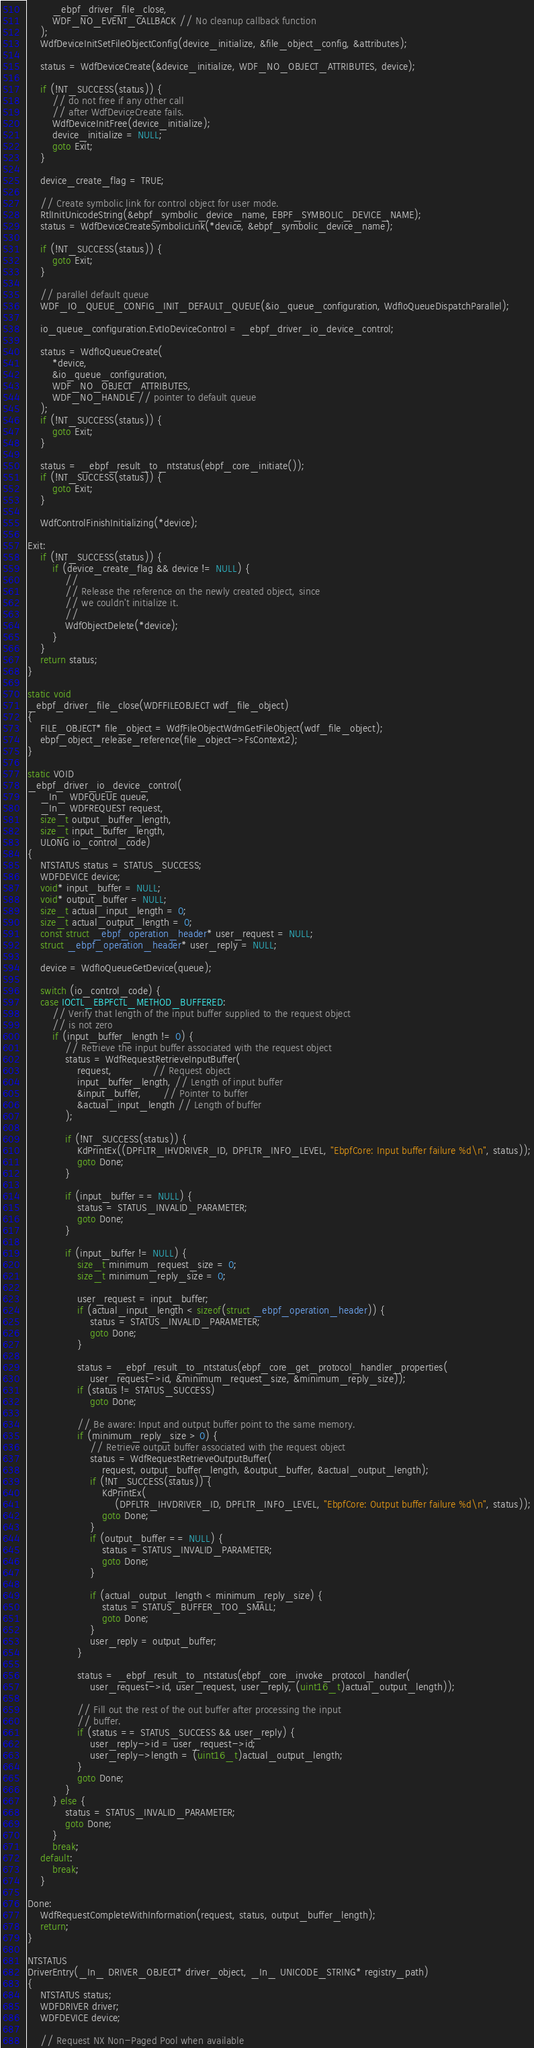Convert code to text. <code><loc_0><loc_0><loc_500><loc_500><_C_>        _ebpf_driver_file_close,
        WDF_NO_EVENT_CALLBACK // No cleanup callback function
    );
    WdfDeviceInitSetFileObjectConfig(device_initialize, &file_object_config, &attributes);

    status = WdfDeviceCreate(&device_initialize, WDF_NO_OBJECT_ATTRIBUTES, device);

    if (!NT_SUCCESS(status)) {
        // do not free if any other call
        // after WdfDeviceCreate fails.
        WdfDeviceInitFree(device_initialize);
        device_initialize = NULL;
        goto Exit;
    }

    device_create_flag = TRUE;

    // Create symbolic link for control object for user mode.
    RtlInitUnicodeString(&ebpf_symbolic_device_name, EBPF_SYMBOLIC_DEVICE_NAME);
    status = WdfDeviceCreateSymbolicLink(*device, &ebpf_symbolic_device_name);

    if (!NT_SUCCESS(status)) {
        goto Exit;
    }

    // parallel default queue
    WDF_IO_QUEUE_CONFIG_INIT_DEFAULT_QUEUE(&io_queue_configuration, WdfIoQueueDispatchParallel);

    io_queue_configuration.EvtIoDeviceControl = _ebpf_driver_io_device_control;

    status = WdfIoQueueCreate(
        *device,
        &io_queue_configuration,
        WDF_NO_OBJECT_ATTRIBUTES,
        WDF_NO_HANDLE // pointer to default queue
    );
    if (!NT_SUCCESS(status)) {
        goto Exit;
    }

    status = _ebpf_result_to_ntstatus(ebpf_core_initiate());
    if (!NT_SUCCESS(status)) {
        goto Exit;
    }

    WdfControlFinishInitializing(*device);

Exit:
    if (!NT_SUCCESS(status)) {
        if (device_create_flag && device != NULL) {
            //
            // Release the reference on the newly created object, since
            // we couldn't initialize it.
            //
            WdfObjectDelete(*device);
        }
    }
    return status;
}

static void
_ebpf_driver_file_close(WDFFILEOBJECT wdf_file_object)
{
    FILE_OBJECT* file_object = WdfFileObjectWdmGetFileObject(wdf_file_object);
    ebpf_object_release_reference(file_object->FsContext2);
}

static VOID
_ebpf_driver_io_device_control(
    _In_ WDFQUEUE queue,
    _In_ WDFREQUEST request,
    size_t output_buffer_length,
    size_t input_buffer_length,
    ULONG io_control_code)
{
    NTSTATUS status = STATUS_SUCCESS;
    WDFDEVICE device;
    void* input_buffer = NULL;
    void* output_buffer = NULL;
    size_t actual_input_length = 0;
    size_t actual_output_length = 0;
    const struct _ebpf_operation_header* user_request = NULL;
    struct _ebpf_operation_header* user_reply = NULL;

    device = WdfIoQueueGetDevice(queue);

    switch (io_control_code) {
    case IOCTL_EBPFCTL_METHOD_BUFFERED:
        // Verify that length of the input buffer supplied to the request object
        // is not zero
        if (input_buffer_length != 0) {
            // Retrieve the input buffer associated with the request object
            status = WdfRequestRetrieveInputBuffer(
                request,             // Request object
                input_buffer_length, // Length of input buffer
                &input_buffer,       // Pointer to buffer
                &actual_input_length // Length of buffer
            );

            if (!NT_SUCCESS(status)) {
                KdPrintEx((DPFLTR_IHVDRIVER_ID, DPFLTR_INFO_LEVEL, "EbpfCore: Input buffer failure %d\n", status));
                goto Done;
            }

            if (input_buffer == NULL) {
                status = STATUS_INVALID_PARAMETER;
                goto Done;
            }

            if (input_buffer != NULL) {
                size_t minimum_request_size = 0;
                size_t minimum_reply_size = 0;

                user_request = input_buffer;
                if (actual_input_length < sizeof(struct _ebpf_operation_header)) {
                    status = STATUS_INVALID_PARAMETER;
                    goto Done;
                }

                status = _ebpf_result_to_ntstatus(ebpf_core_get_protocol_handler_properties(
                    user_request->id, &minimum_request_size, &minimum_reply_size));
                if (status != STATUS_SUCCESS)
                    goto Done;

                // Be aware: Input and output buffer point to the same memory.
                if (minimum_reply_size > 0) {
                    // Retrieve output buffer associated with the request object
                    status = WdfRequestRetrieveOutputBuffer(
                        request, output_buffer_length, &output_buffer, &actual_output_length);
                    if (!NT_SUCCESS(status)) {
                        KdPrintEx(
                            (DPFLTR_IHVDRIVER_ID, DPFLTR_INFO_LEVEL, "EbpfCore: Output buffer failure %d\n", status));
                        goto Done;
                    }
                    if (output_buffer == NULL) {
                        status = STATUS_INVALID_PARAMETER;
                        goto Done;
                    }

                    if (actual_output_length < minimum_reply_size) {
                        status = STATUS_BUFFER_TOO_SMALL;
                        goto Done;
                    }
                    user_reply = output_buffer;
                }

                status = _ebpf_result_to_ntstatus(ebpf_core_invoke_protocol_handler(
                    user_request->id, user_request, user_reply, (uint16_t)actual_output_length));

                // Fill out the rest of the out buffer after processing the input
                // buffer.
                if (status == STATUS_SUCCESS && user_reply) {
                    user_reply->id = user_request->id;
                    user_reply->length = (uint16_t)actual_output_length;
                }
                goto Done;
            }
        } else {
            status = STATUS_INVALID_PARAMETER;
            goto Done;
        }
        break;
    default:
        break;
    }

Done:
    WdfRequestCompleteWithInformation(request, status, output_buffer_length);
    return;
}

NTSTATUS
DriverEntry(_In_ DRIVER_OBJECT* driver_object, _In_ UNICODE_STRING* registry_path)
{
    NTSTATUS status;
    WDFDRIVER driver;
    WDFDEVICE device;

    // Request NX Non-Paged Pool when available</code> 